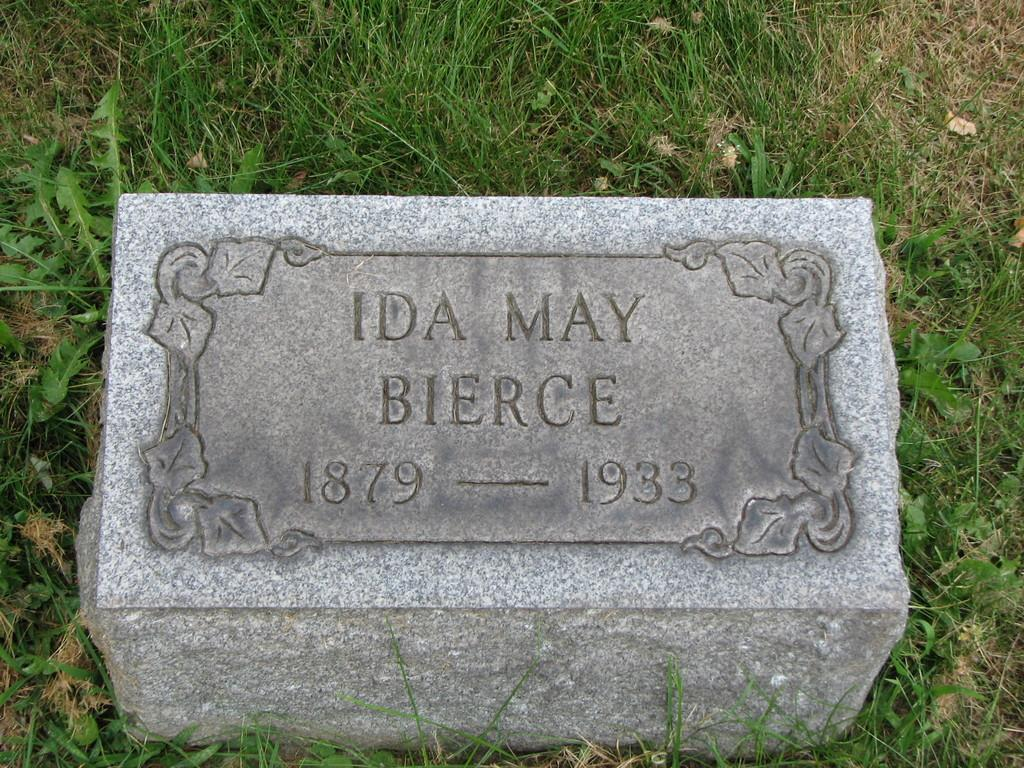What is the main object in the image? There is a stone in the image. Where is the stone located? The stone is on the grass. What is the condition of the twig near the stone in the image? There is no twig present in the image. What type of ornament is hanging from the stone in the image? There is no ornament hanging from the stone in the image; it is just a stone on the grass. 